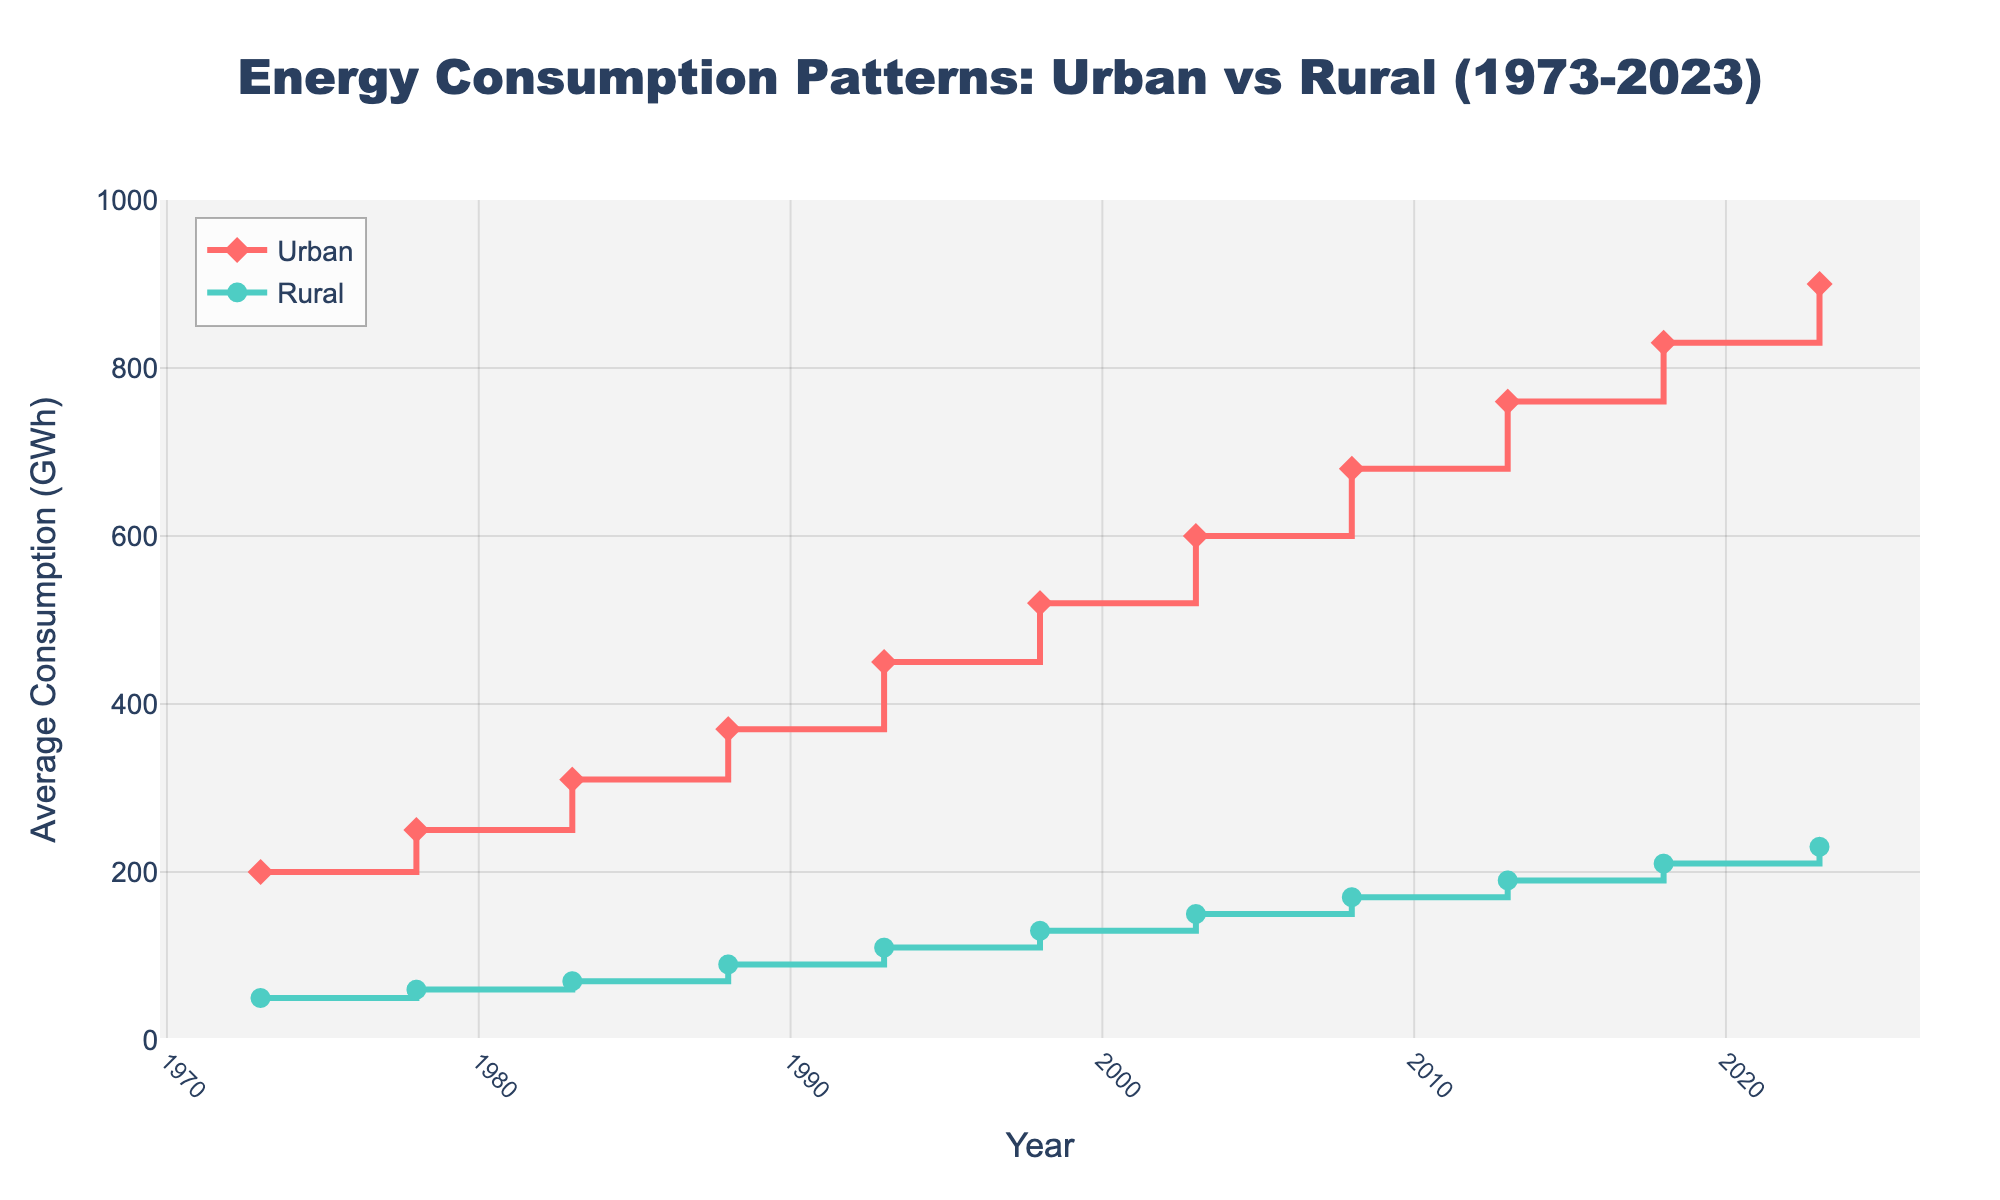What is the title of the figure? The title is usually located at the top of the plot. It provides a summary of what the plot represents.
Answer: Energy Consumption Patterns: Urban vs Rural (1973-2023) What color represents urban energy consumption? Colors help differentiate lines in the plot. The color for the urban line can be identified by looking at the legend.
Answer: Red How many years are represented in the plot? Count the number of data points (markers) along the x-axis, which shows the years.
Answer: 11 What is the average energy consumption for rural areas in 2023? Locate the data marker for rural energy consumption in 2023 on the x-axis and read the corresponding value on the y-axis.
Answer: 230 GWh Which year shows the highest energy consumption in rural areas? Look for the highest marker on the rural line.
Answer: 2023 What is the difference in energy consumption between urban and rural areas in 1993? Find the values for both urban and rural areas in 1993 and subtract the rural value from the urban value. Urban (450) - Rural (110) = 340
Answer: 340 GWh Which area had a greater increase in energy consumption from 1973 to 2023, urban or rural? Calculate the difference in values between 1973 and 2023 for both areas and compare. Urban increased by 700 (900-200). Rural increased by 180 (230-50). Urban had the greater increase.
Answer: Urban What is the average energy consumption for rural areas between 1973 and 2023? Add the rural data points and divide by the number of years. (50+60+70+90+110+130+150+170+190+210+230)/11 = 135.45
Answer: 135.45 GWh Between 1983 and 1993, which area saw a greater increase in energy consumption, urban or rural? Calculate the difference for both areas between the two years and compare. Urban (450-310) = 140, Rural (110-70) = 40. Urban area had greater increase.
Answer: Urban Is there a year where the energy consumption increased equally for both areas? Compare the annual increases for each year to find a match. Year-by-year, no such year is found.
Answer: No 